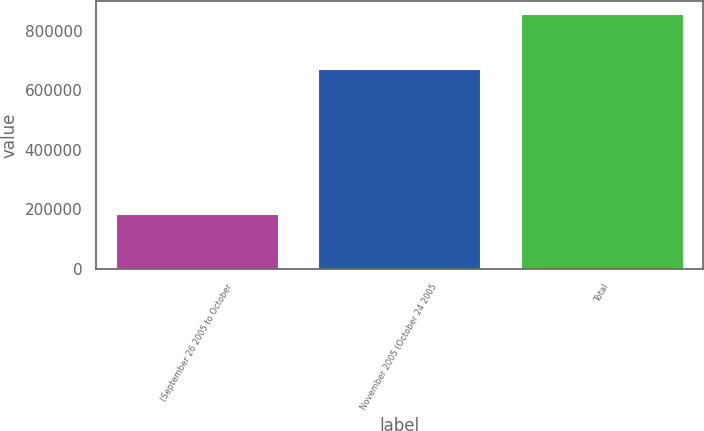<chart> <loc_0><loc_0><loc_500><loc_500><bar_chart><fcel>(September 26 2005 to October<fcel>November 2005 (October 24 2005<fcel>Total<nl><fcel>185000<fcel>672300<fcel>857300<nl></chart> 